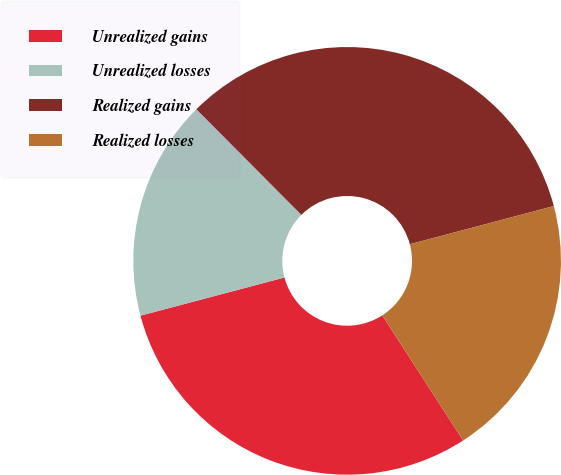Convert chart. <chart><loc_0><loc_0><loc_500><loc_500><pie_chart><fcel>Unrealized gains<fcel>Unrealized losses<fcel>Realized gains<fcel>Realized losses<nl><fcel>30.0%<fcel>16.67%<fcel>33.33%<fcel>20.0%<nl></chart> 